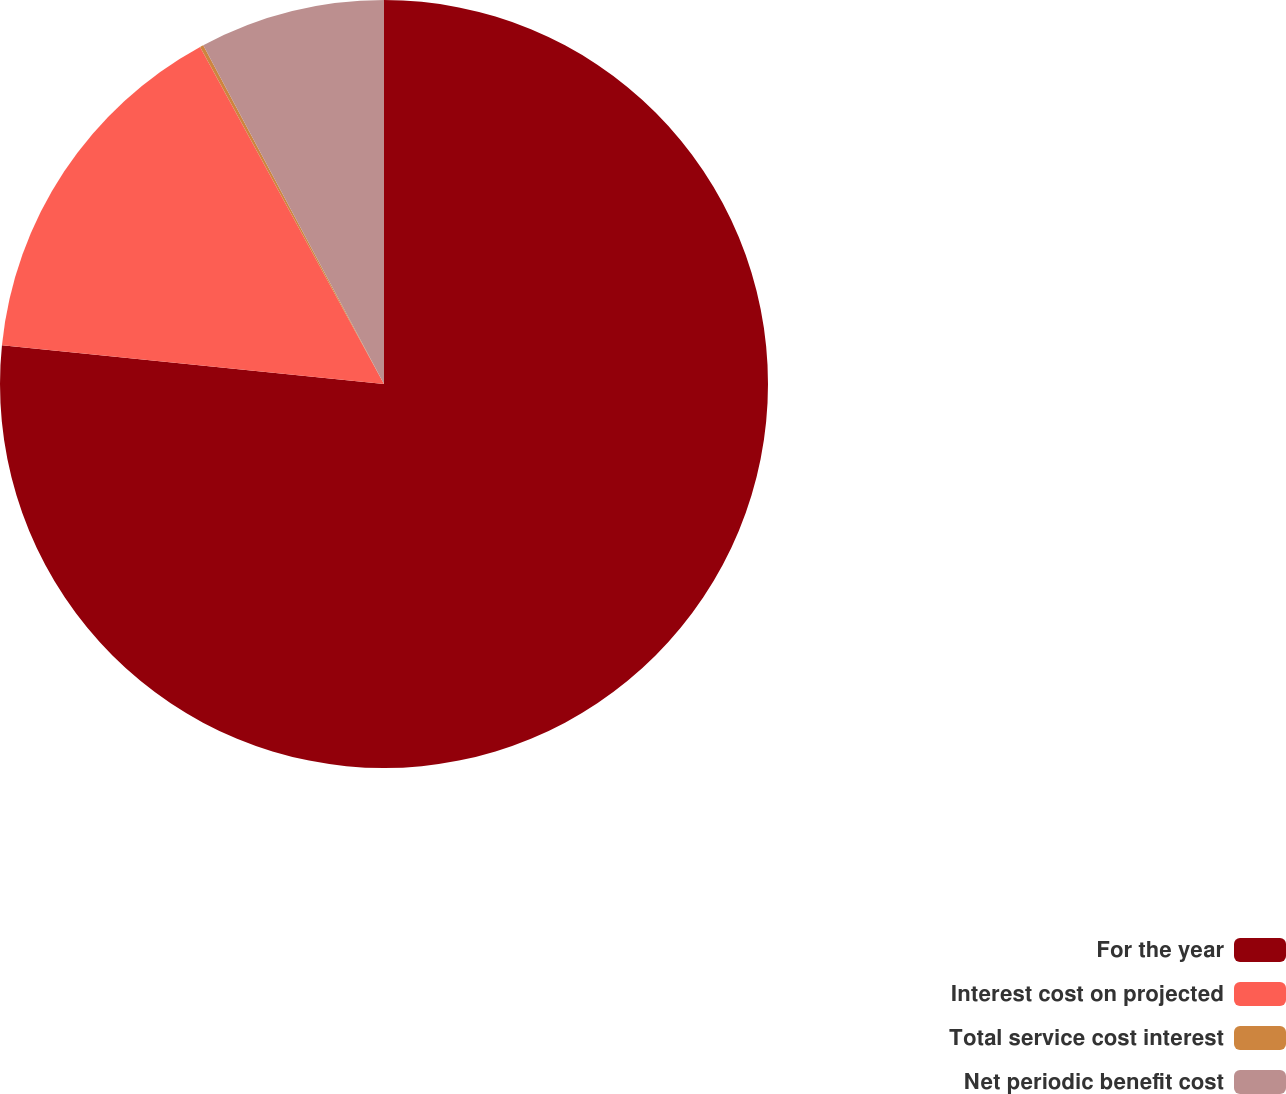<chart> <loc_0><loc_0><loc_500><loc_500><pie_chart><fcel>For the year<fcel>Interest cost on projected<fcel>Total service cost interest<fcel>Net periodic benefit cost<nl><fcel>76.61%<fcel>15.44%<fcel>0.15%<fcel>7.8%<nl></chart> 